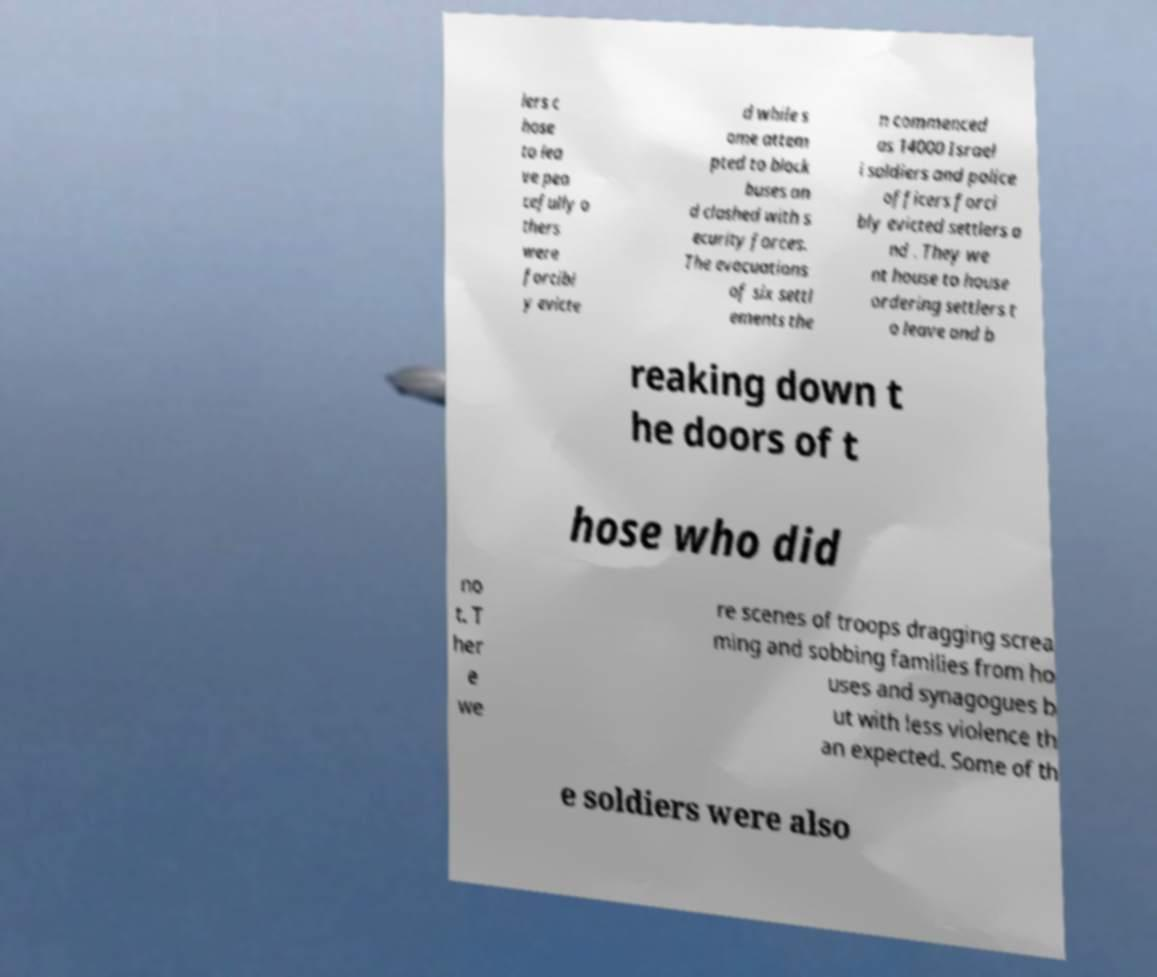Could you extract and type out the text from this image? lers c hose to lea ve pea cefully o thers were forcibl y evicte d while s ome attem pted to block buses an d clashed with s ecurity forces. The evacuations of six settl ements the n commenced as 14000 Israel i soldiers and police officers forci bly evicted settlers a nd . They we nt house to house ordering settlers t o leave and b reaking down t he doors of t hose who did no t. T her e we re scenes of troops dragging screa ming and sobbing families from ho uses and synagogues b ut with less violence th an expected. Some of th e soldiers were also 